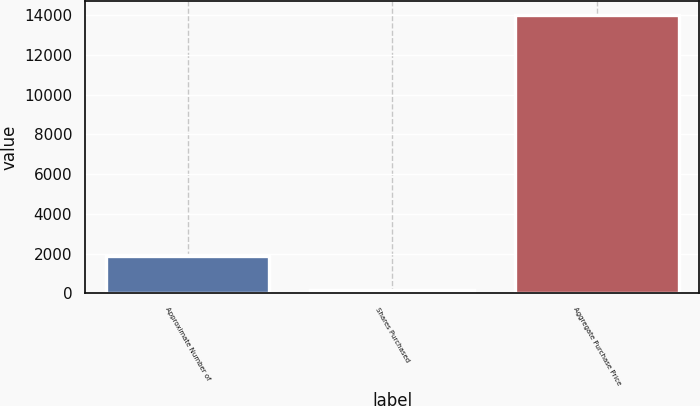Convert chart to OTSL. <chart><loc_0><loc_0><loc_500><loc_500><bar_chart><fcel>Approximate Number of<fcel>Shares Purchased<fcel>Aggregate Purchase Price<nl><fcel>1870<fcel>180<fcel>13997<nl></chart> 